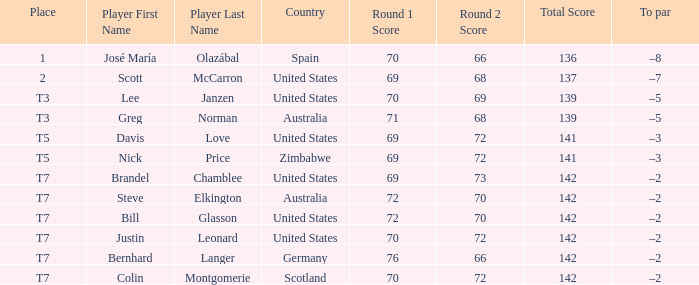WHich Place has a To par of –2, and a Player of bernhard langer? T7. 